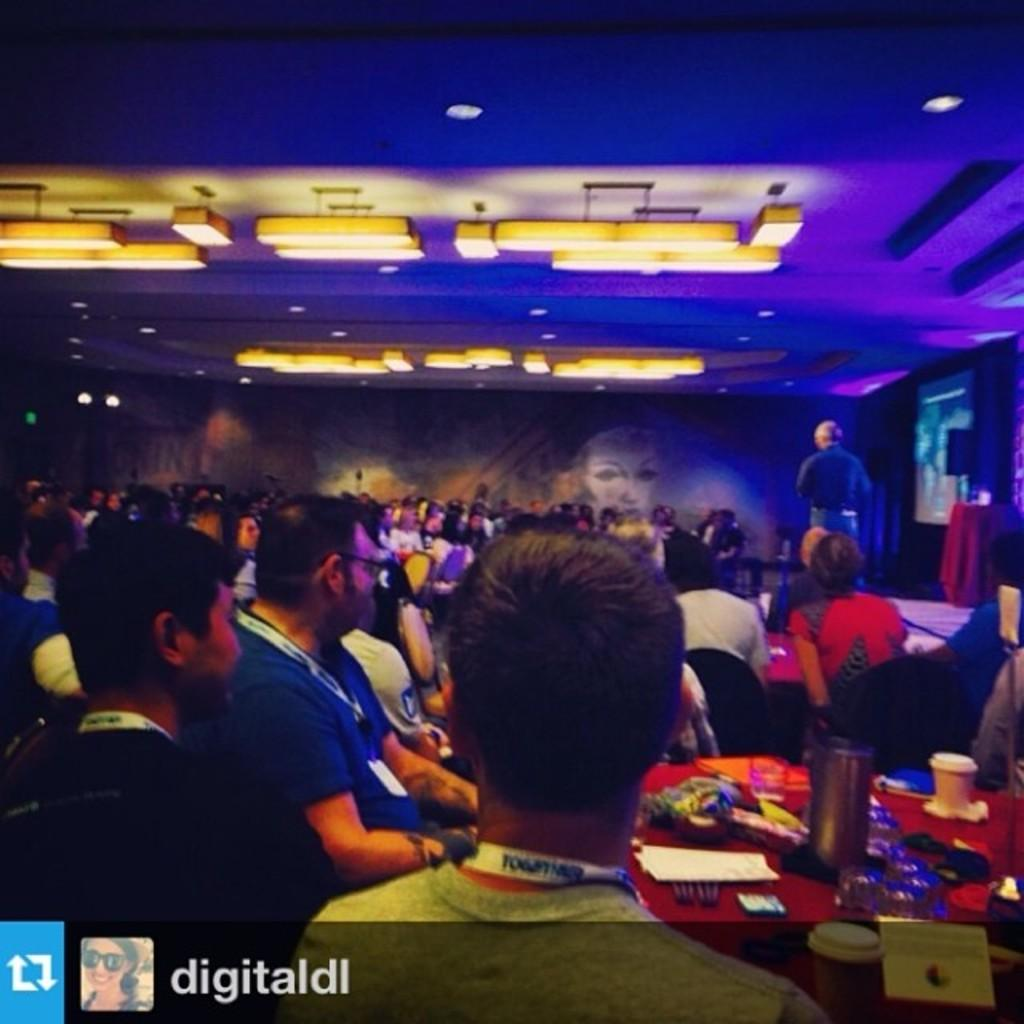What are the people in the image doing? The people in the image are sitting on chairs. Is there anyone standing in the image? Yes, there is a man standing in the image. What can be seen at the top of the image? There are lights visible at the top of the image. What type of house is visible in the image? There is no house present in the image. Can you tell me how many people are taking a bath in the image? There is no bath or people taking a bath in the image. 